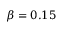<formula> <loc_0><loc_0><loc_500><loc_500>\beta = 0 . 1 5</formula> 